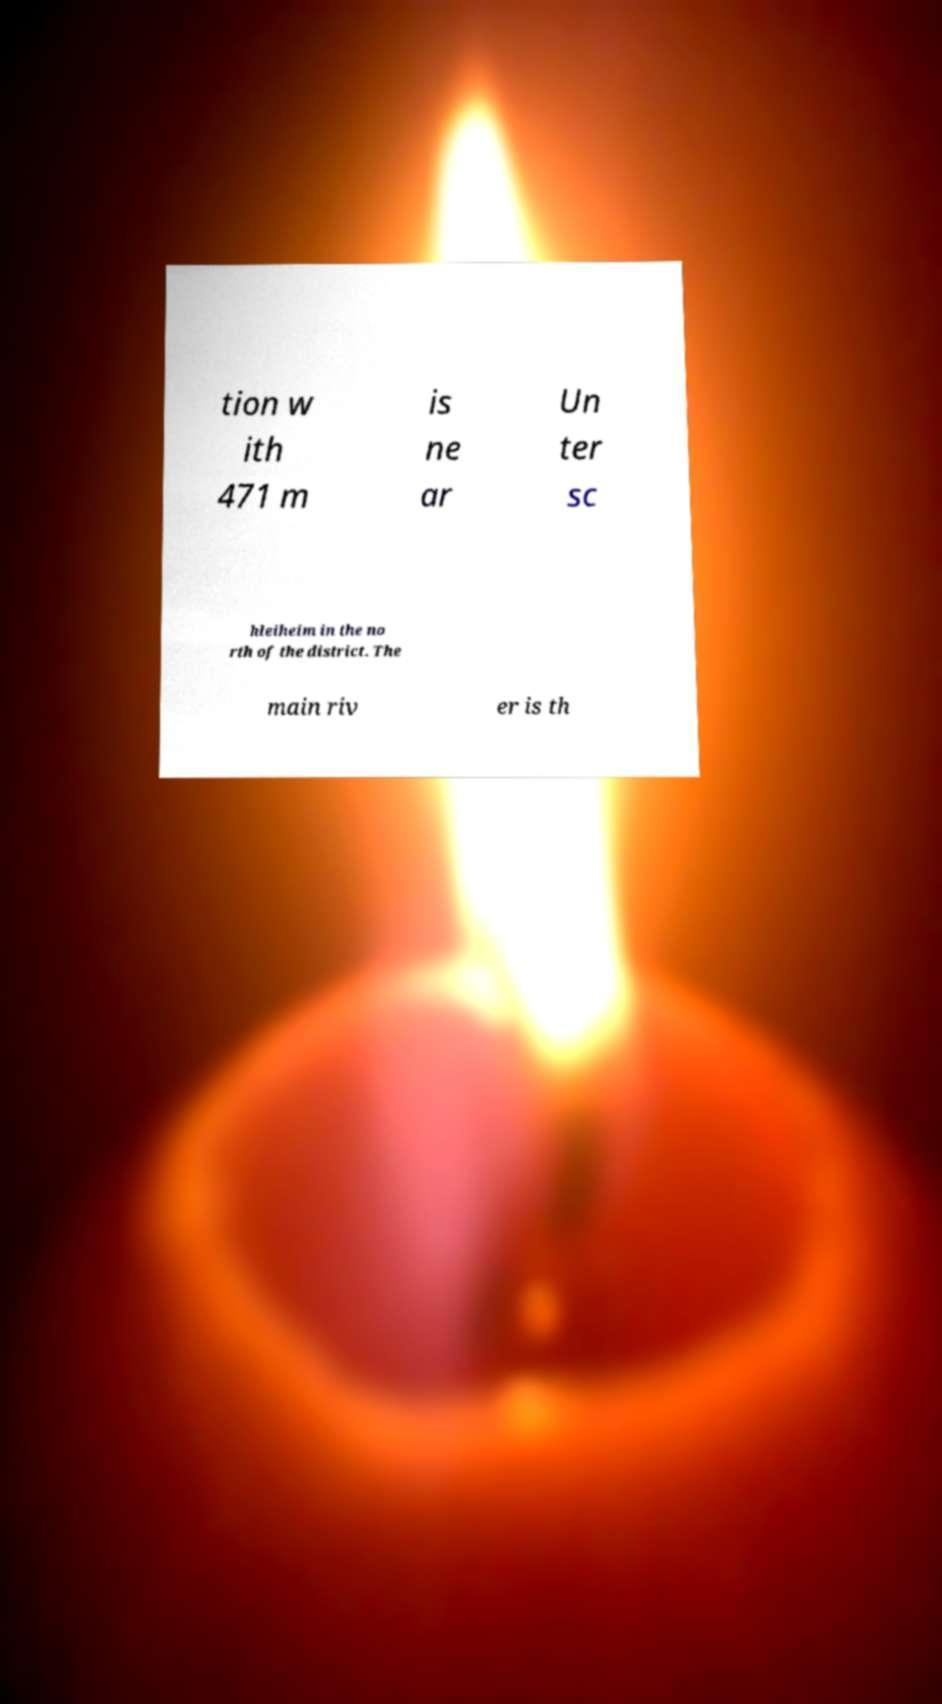For documentation purposes, I need the text within this image transcribed. Could you provide that? tion w ith 471 m is ne ar Un ter sc hleiheim in the no rth of the district. The main riv er is th 